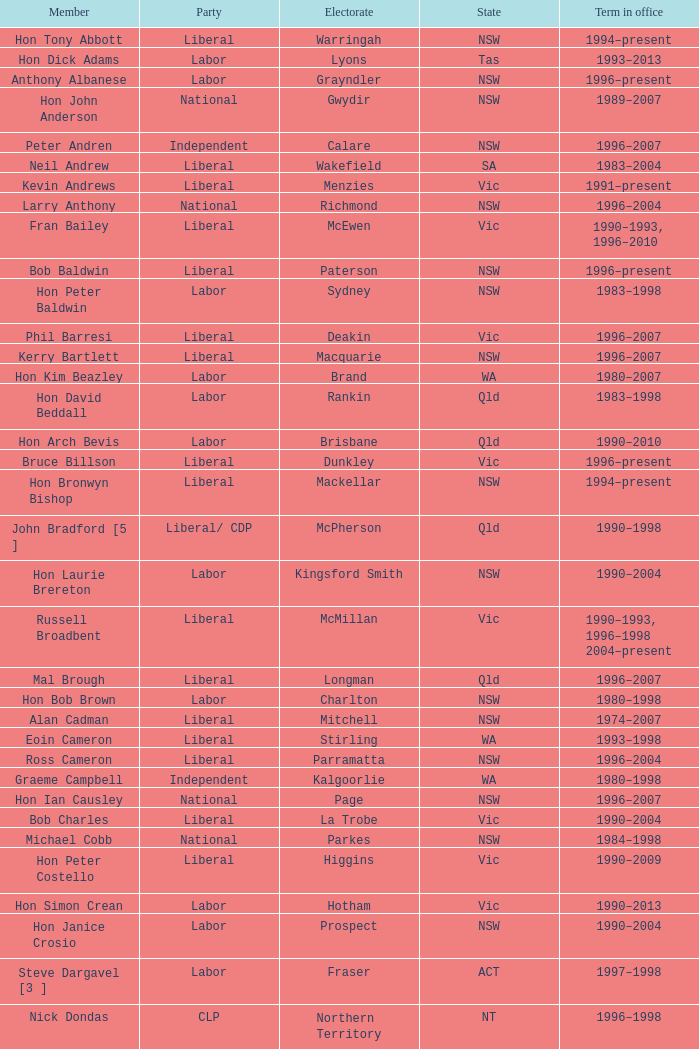What state did Hon David Beddall belong to? Qld. 